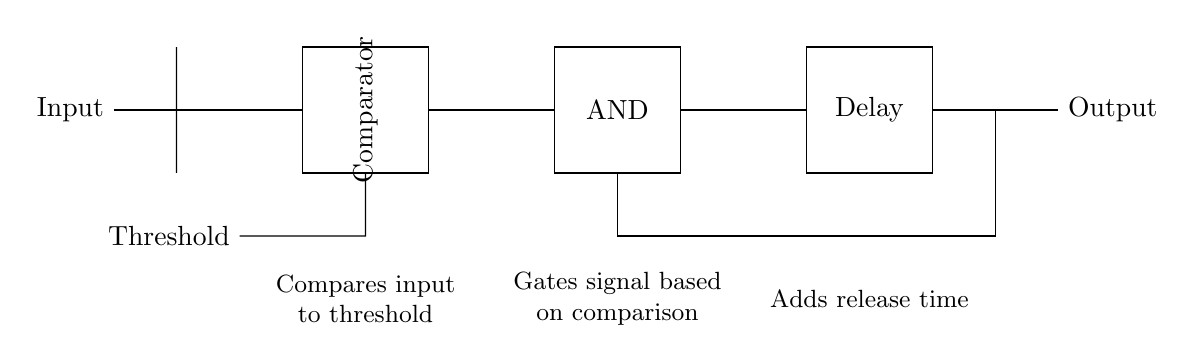What is the input of this circuit? The input of the circuit is labeled as "Input," which is the starting point for the signal being processed.
Answer: Input What component is used to compare the input signal? The component that compares the input signal is labeled as "Comparator," indicating its function in evaluating the input against a reference.
Answer: Comparator What does the AND gate control in this circuit? The AND gate is responsible for gating the signal based on the output of the comparator; it will allow signals to pass only if certain conditions are met.
Answer: Gating signal What is the purpose of the threshold in this noise gate circuit? The purpose of the threshold is to set a limit that the input signal must exceed for the circuit to enable the output, effectively filtering out unwanted noise.
Answer: Limit for output What is the role of the delay component? The delay component adds time before the output responds to changes in the input signal, helping to smooth out variations and prevent abrupt changes in output.
Answer: Smoothing output How does the feedback connection affect the AND gate? The feedback connection from the output to the AND gate influences its behavior, allowing previous output states to affect current decision-making, enhancing the stability of the noise gating process.
Answer: Influences behavior What type of circuit is this example illustrating? This circuit is illustrating a noise gate using logic gates, specifically designed to reduce unwanted background noise in audio recordings.
Answer: Noise gate 